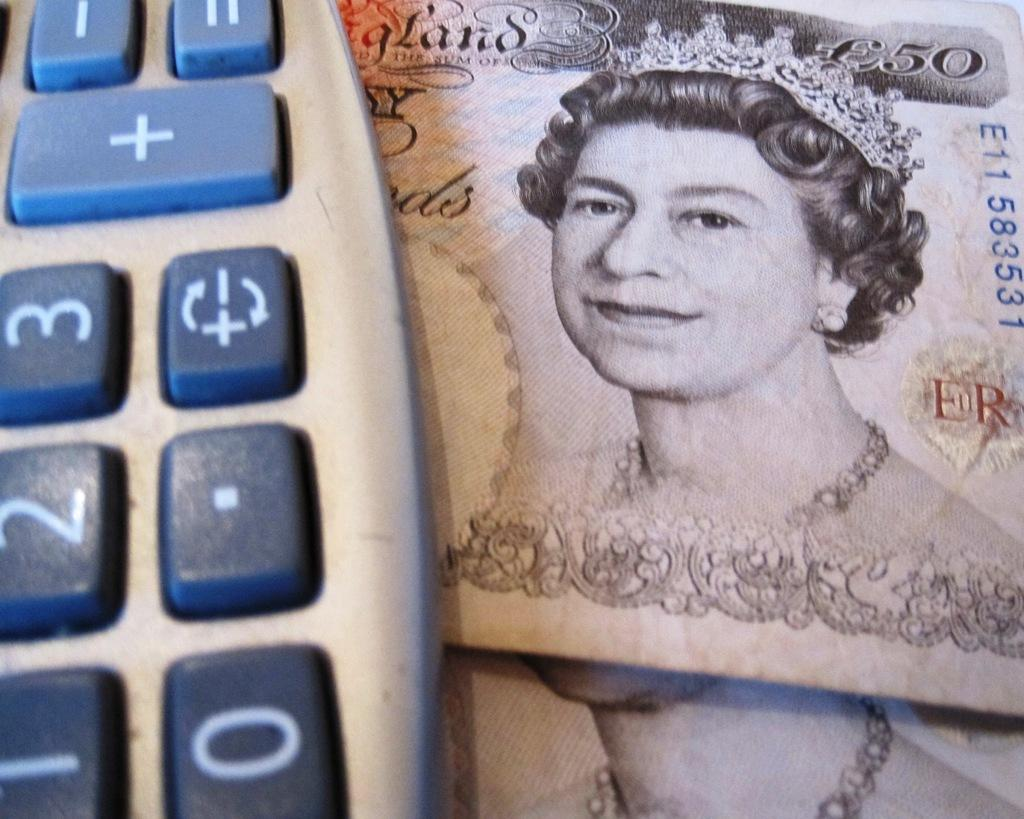What type of financial objects are present in the image? There are currency notes in the image. What other object can be seen in the image? There is a keyboard in the image. How many deer are visible in the image? There are no deer present in the image. What type of watch is featured on the keyboard in the image? There is no watch present in the image, and the keyboard is not associated with a watch. 